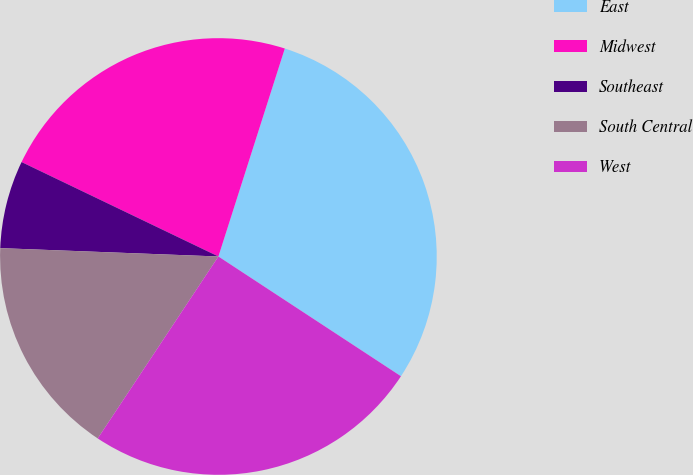Convert chart. <chart><loc_0><loc_0><loc_500><loc_500><pie_chart><fcel>East<fcel>Midwest<fcel>Southeast<fcel>South Central<fcel>West<nl><fcel>29.32%<fcel>22.8%<fcel>6.51%<fcel>16.29%<fcel>25.08%<nl></chart> 